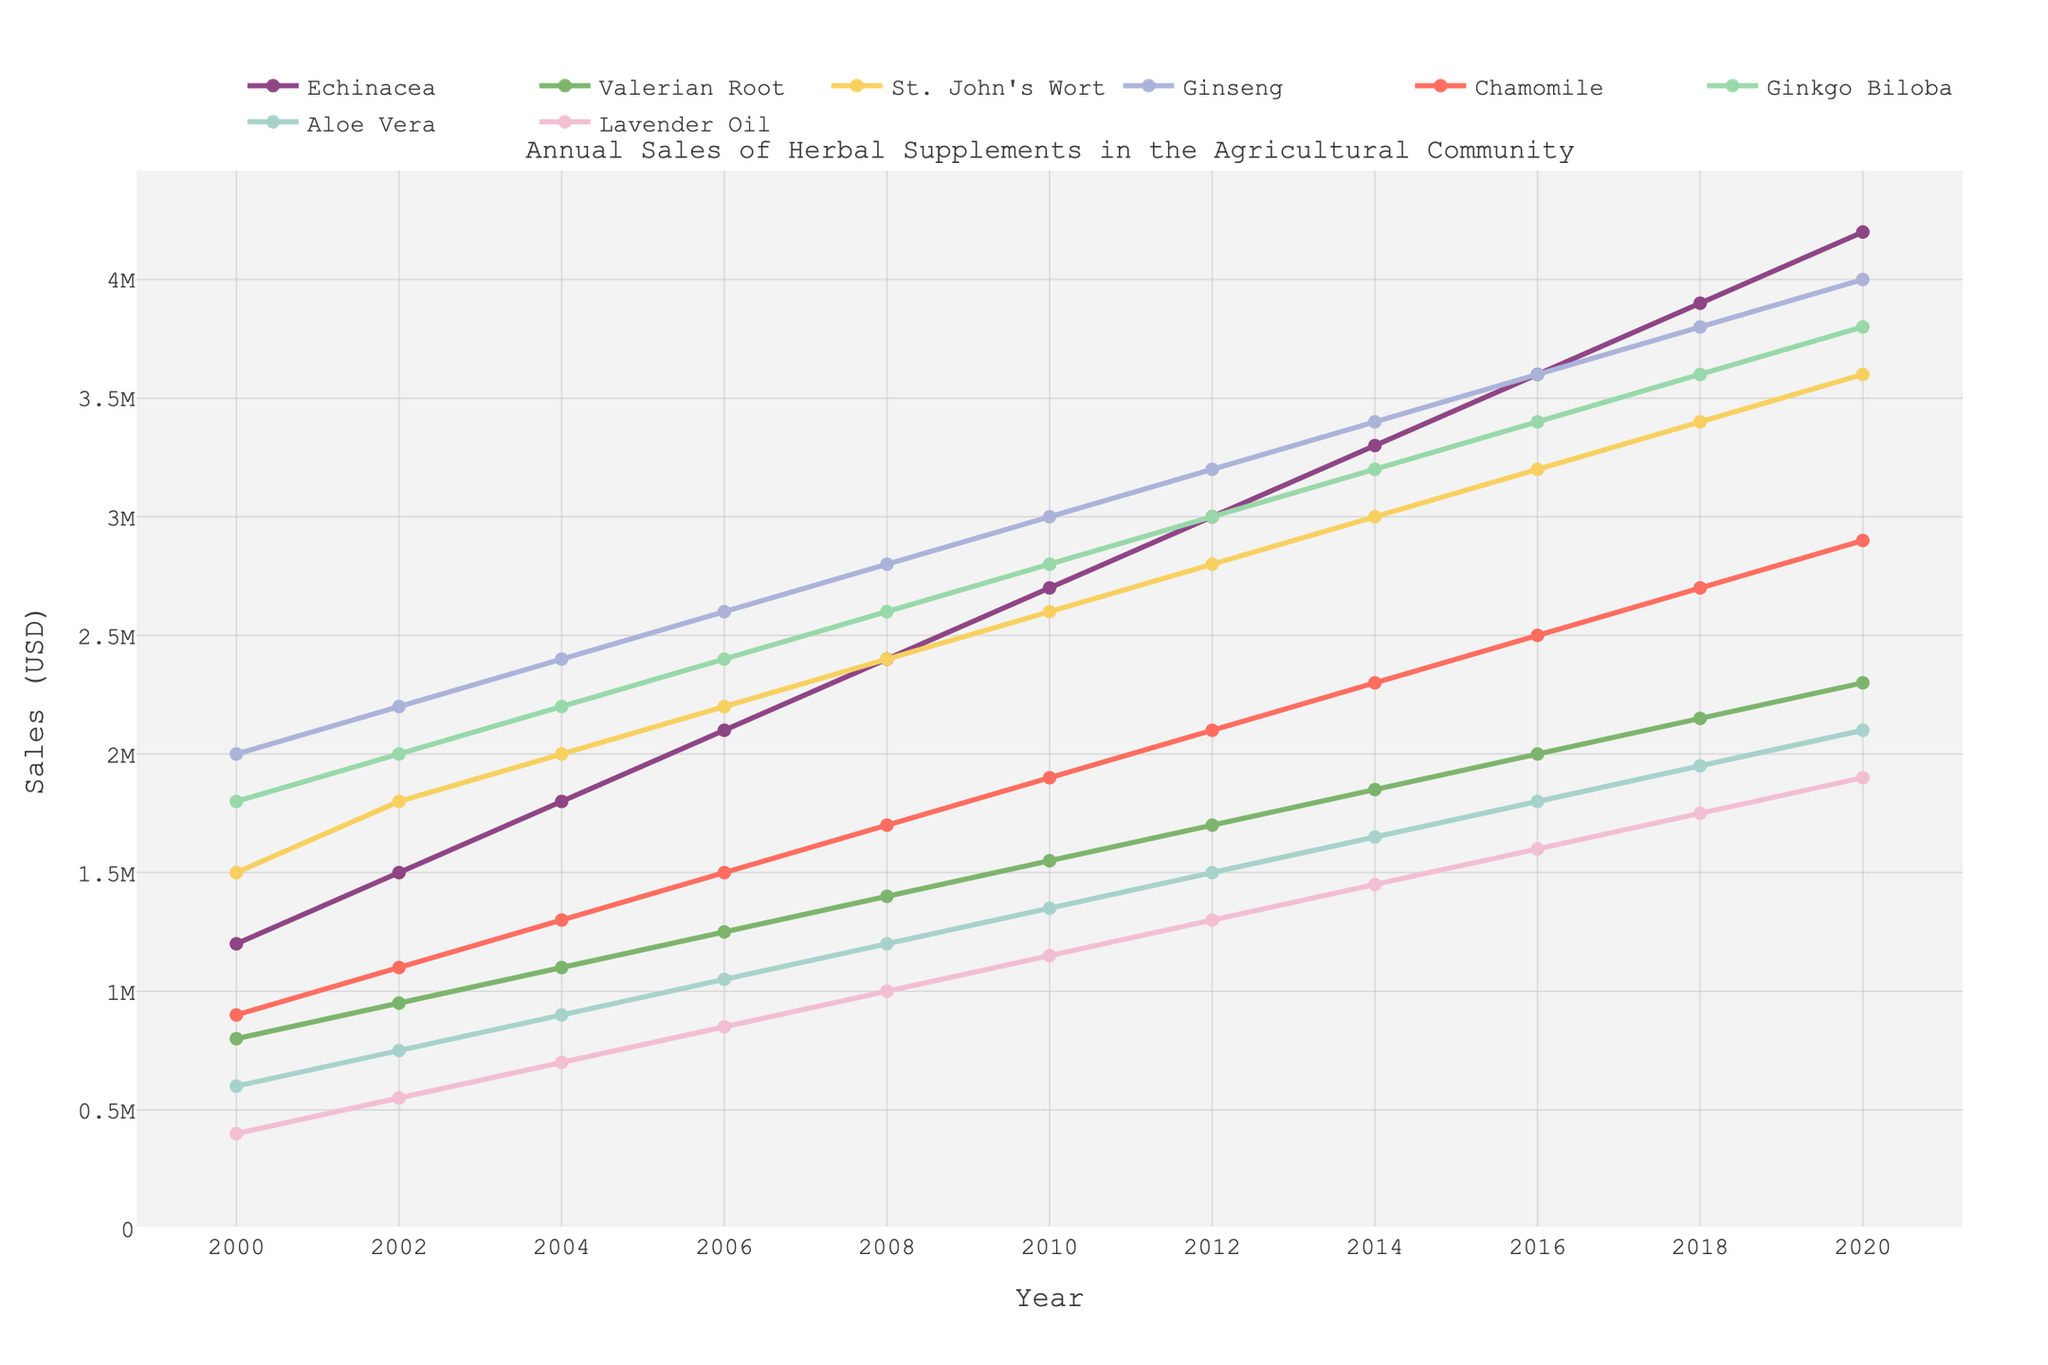What is the total sales of Echinacea and Ginseng in the year 2000? To find the total sales for Echinacea and Ginseng in 2000, add their sales figures: Echinacea (1,200,000) + Ginseng (2,000,000) = 3,200,000
Answer: 3,200,000 Which herbal supplement had the highest sales in 2020? In 2020, compare the sales figures of all the herbal supplements to find the highest one. Ginseng had the highest sales at 4,000,000 USD.
Answer: Ginseng Between 2008 and 2014, which herbal supplement showed the highest increase in sales? Calculate the difference in sales for each supplement between 2008 and 2014. Echinacea increased by 900,000, Valerian Root by 450,000, St. John's Wort by 600,000, Ginseng by 600,000, Chamomile by 600,000, Ginkgo Biloba by 600,000, Aloe Vera by 450,000, and Lavender Oil by 450,000. Echinacea had the highest increase.
Answer: Echinacea By how much did the sales of Chamomile increase from 2010 to 2020? Subtract the sales figure of Chamomile in 2010 from its sales figure in 2020: 2,900,000 - 1,900,000 = 1,000,000
Answer: 1,000,000 Which two herbal supplements had the closest sales figures in 2016? Compare the sales figures of each pair of herbal supplements in 2016. St. John's Wort and Ginseng both had sales figures of 3,600,000.
Answer: St. John's Wort and Ginseng What is the average sales of Ginkgo Biloba from 2000 to 2020? Add up Ginkgo Biloba’s sales figures for each year and divide by the number of years: (1,800,000 + 2,000,000 + 2,200,000 + 2,400,000 + 2,600,000 + 2,800,000 + 3,000,000 + 3,200,000 + 3,400,000 + 3,600,000 + 3,800,000)/11 = 2,927,273
Answer: 2,927,273 In which year did Aloe Vera surpass 1 million in sales? Look at Aloe Vera's sales figures over the years. Aloe Vera surpassed 1 million in 2006 when its sales reached 1,050,000 USD.
Answer: 2006 What can be said about the trend of Lavender Oil sales between 2000 and 2020? Examine the Lavender Oil sales figures from 2000 to 2020. The sales show a consistent upward trend year-over-year.
Answer: Consistent upward trend How much more were the sales of Valerian Root compared to Aloe Vera in 2018? Subtract Aloe Vera’s sales from Valerian Root’s sales in 2018: 2,150,000 - 1,950,000 = 200,000
Answer: 200,000 